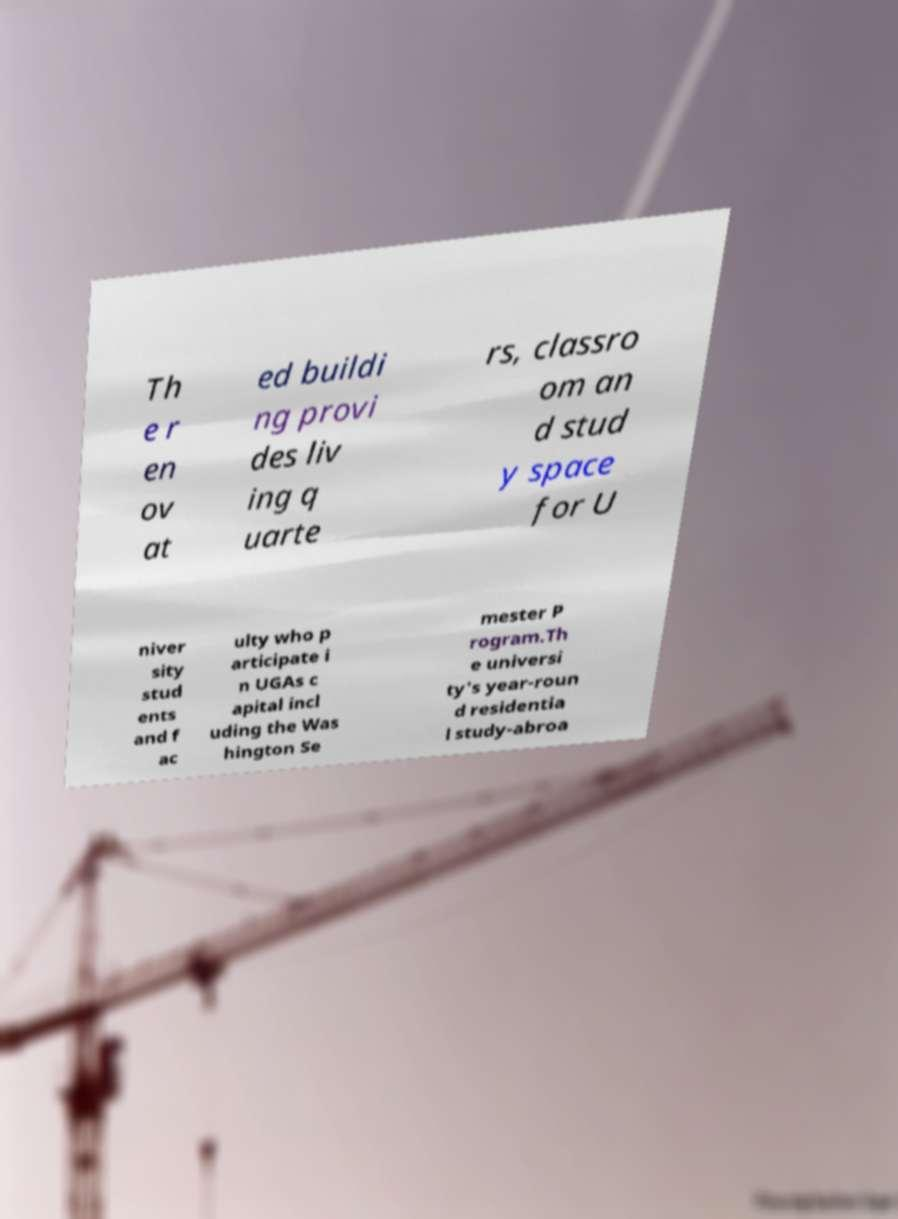I need the written content from this picture converted into text. Can you do that? Th e r en ov at ed buildi ng provi des liv ing q uarte rs, classro om an d stud y space for U niver sity stud ents and f ac ulty who p articipate i n UGAs c apital incl uding the Was hington Se mester P rogram.Th e universi ty's year-roun d residentia l study-abroa 